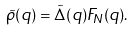Convert formula to latex. <formula><loc_0><loc_0><loc_500><loc_500>\tilde { \rho } ( q ) = \tilde { \Delta } ( q ) F _ { N } ( q ) .</formula> 